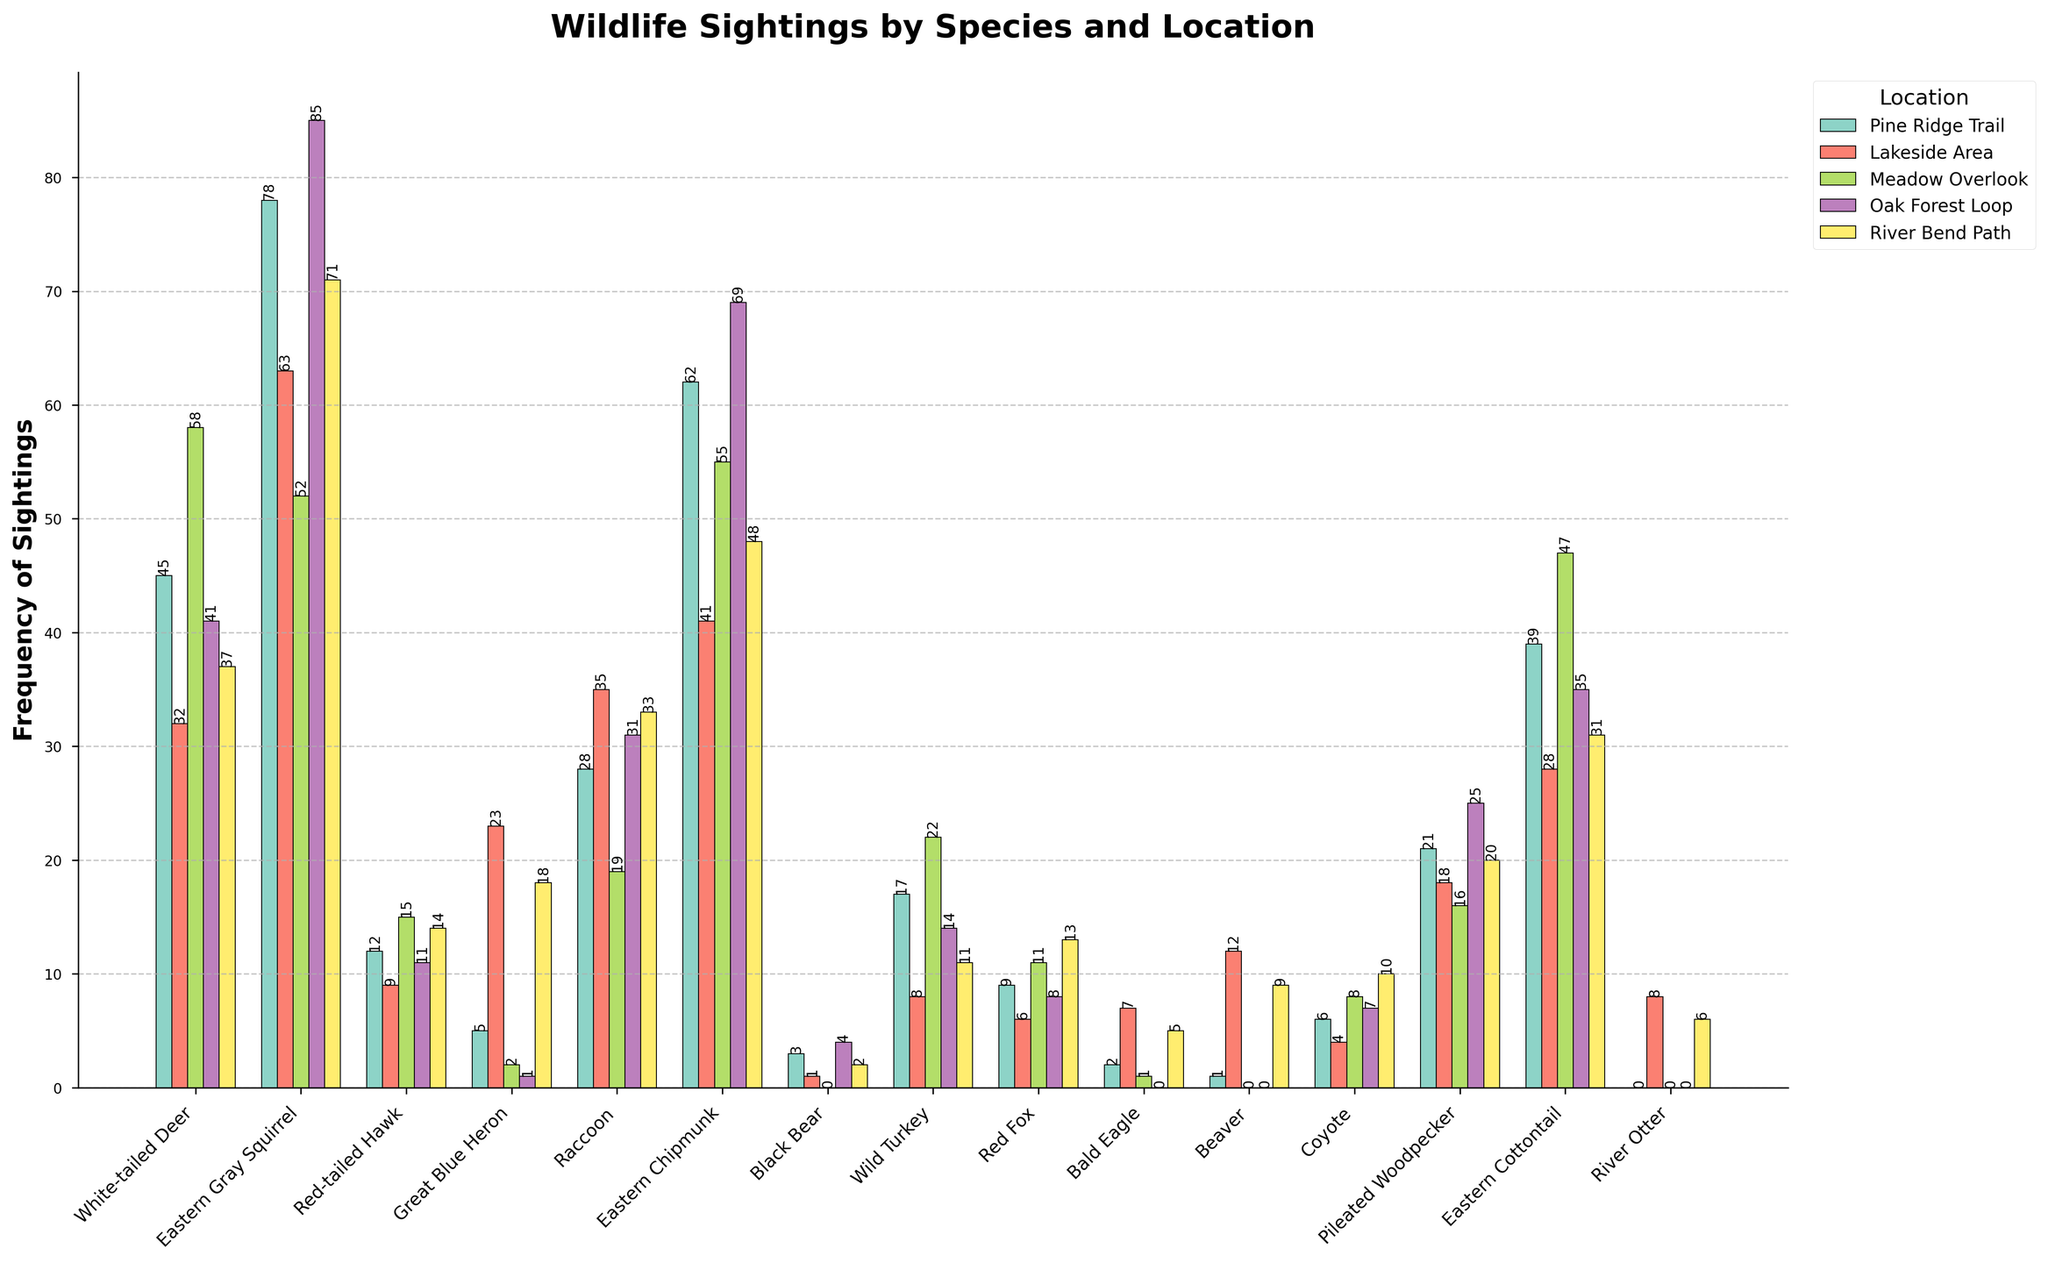Which species has the highest overall frequency of wildlife sightings across all locations? Look at the bars in the chart for each location, sum the frequencies for each species, and identify the species with the highest sum. The Eastern Gray Squirrel appears to have the highest bar heights across multiple locations.
Answer: Eastern Gray Squirrel Compare the frequency of White-tailed Deer sightings on Pine Ridge Trail and River Bend Path. Which has more sightings and by how much? Find the bars corresponding to White-tailed Deer in Pine Ridge Trail and River Bend Path. Pine Ridge Trail has a bar height of 45, and River Bend Path has 37. The difference is 45 - 37 = 8.
Answer: Pine Ridge Trail by 8 sightings What's the total number of sightings for Great Blue Heron? Sum the bar heights for Great Blue Heron from all locations. The respective values are 5, 23, 2, 1, and 18, making the sum 5 + 23 + 2 + 1 + 18 = 49.
Answer: 49 Which location has the least number of Bald Eagle sightings? Compare the heights of the bars representing Bald Eagle sightings across different locations. The Meadow Overlook and Oak Forest Loop both have the shortest bar, indicating 0 sightings for Bald Eagle. Hence, these are tied for the least.
Answer: Meadow Overlook and Oak Forest Loop How many more Eastern Chipmunk sightings are there on Oak Forest Loop compared to Lakeside Area? Identify the bar heights for Eastern Chipmunks in Oak Forest Loop (69) and Lakeside Area (41), and then find the difference: 69 - 41 = 28.
Answer: 28 What is the average frequency of Red-tailed Hawk sightings across all locations? Sum the frequencies for Red-tailed Hawk (12, 9, 15, 11, 14) and divide by the number of locations (5): (12 + 9 + 15 + 11 + 14)/5 = 61/5 = 12.2.
Answer: 12.2 Which species has the second highest frequency of sightings on Meadow Overlook? Look at the bars in Meadow Overlook and order the species by height. The highest is White-tailed Deer (58) and the second highest is Eastern Chipmunk (55).
Answer: Eastern Chipmunk Is the frequency of Coyote sightings on River Bend Path greater than the frequency on Lakeside Area? Compare the height of the bars representing Coyote sightings in River Bend Path (10) and Lakeside Area (4). Since 10 is greater than 4, the frequency on River Bend Path is greater.
Answer: Yes How many species have sightings in Oak Forest Loop that are greater than 60? Examine the bar heights for all species in Oak Forest Loop. The Eastern Gray Squirrel (85), Eastern Chipmunk (69) have sightings greater than 60, totaling 2 species.
Answer: 2 Which species has the lowest frequency of sightings in any location? Look at all the bars and identify the one with the smallest height. The Beaver and Coyote (both 0 sightings in Meadow Overlook and Oak Forest Loop respectively) have the lowest frequency.
Answer: Beaver and Coyote 